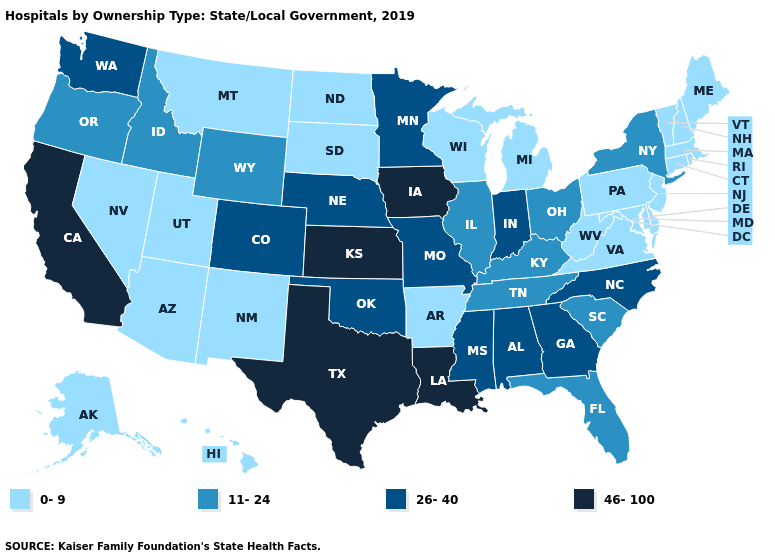Does the map have missing data?
Keep it brief. No. What is the value of Alaska?
Write a very short answer. 0-9. Does Connecticut have the same value as Nevada?
Write a very short answer. Yes. What is the value of Mississippi?
Be succinct. 26-40. Name the states that have a value in the range 46-100?
Give a very brief answer. California, Iowa, Kansas, Louisiana, Texas. Name the states that have a value in the range 46-100?
Write a very short answer. California, Iowa, Kansas, Louisiana, Texas. Among the states that border Virginia , does North Carolina have the lowest value?
Write a very short answer. No. Is the legend a continuous bar?
Write a very short answer. No. Does New York have the highest value in the Northeast?
Keep it brief. Yes. What is the value of Arizona?
Give a very brief answer. 0-9. Name the states that have a value in the range 11-24?
Write a very short answer. Florida, Idaho, Illinois, Kentucky, New York, Ohio, Oregon, South Carolina, Tennessee, Wyoming. What is the highest value in the USA?
Keep it brief. 46-100. Which states have the lowest value in the USA?
Keep it brief. Alaska, Arizona, Arkansas, Connecticut, Delaware, Hawaii, Maine, Maryland, Massachusetts, Michigan, Montana, Nevada, New Hampshire, New Jersey, New Mexico, North Dakota, Pennsylvania, Rhode Island, South Dakota, Utah, Vermont, Virginia, West Virginia, Wisconsin. Does Minnesota have the same value as Oklahoma?
Quick response, please. Yes. 